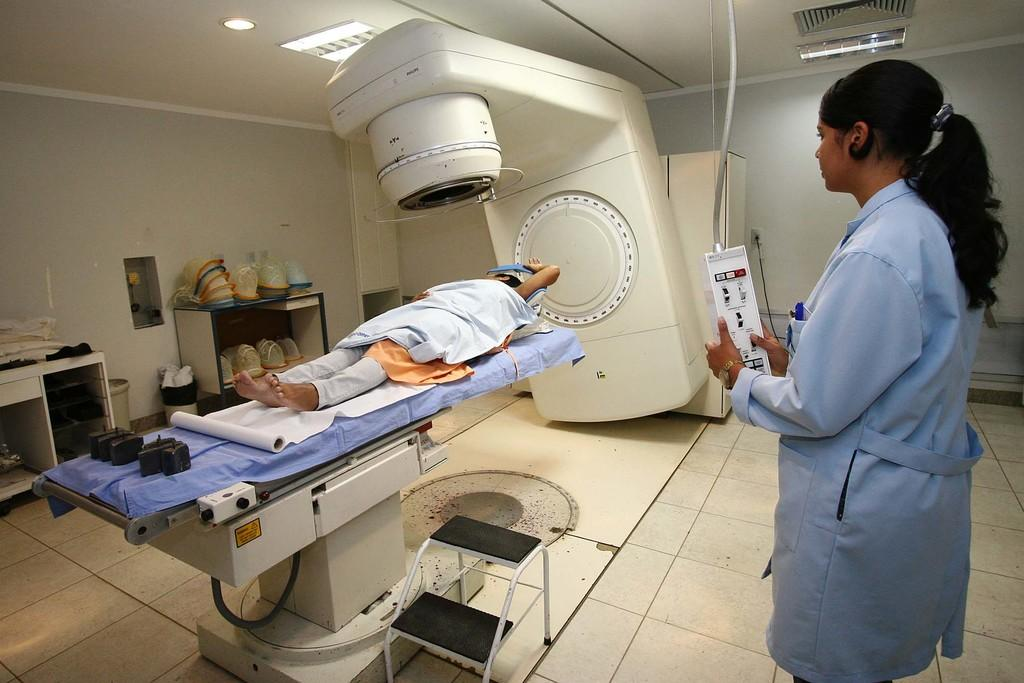How many people are in the image? There are two people in the image. What is the position of one of the people? One person is lying down. What is the position of the other person? The other person is standing. What is the standing person holding? The standing person is holding an object. What color is the floor in the image? The floor in the image is white. Can you describe the lighting in the image? There is light in the image. Can you see any mittens on the people in the image? There are no mittens visible in the image. What type of bread is being used as a prop in the image? There is no bread present in the image. 